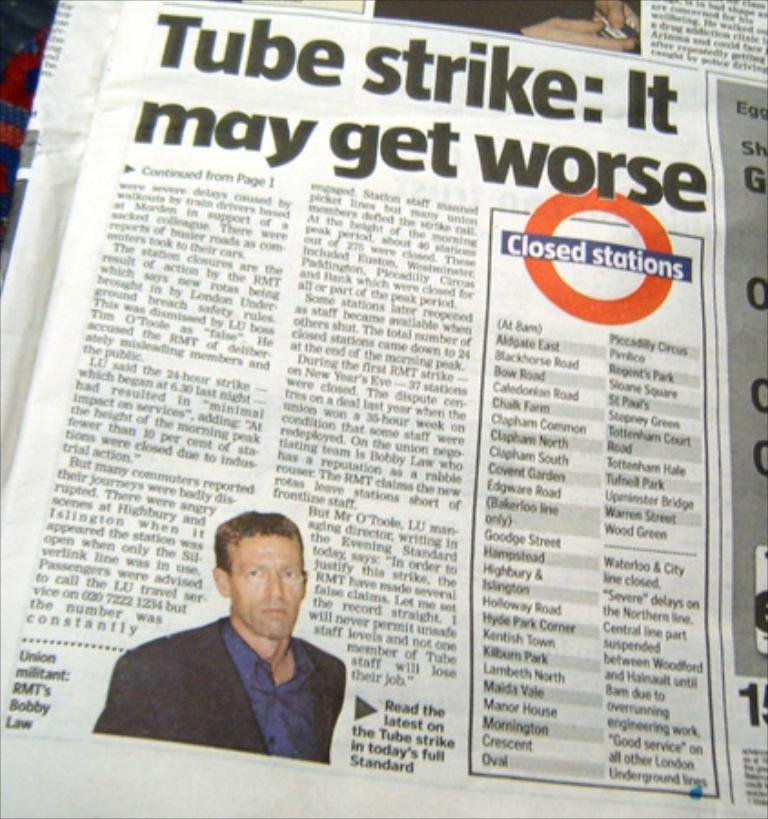<image>
Provide a brief description of the given image. A Tube Strike article is in the paper. 